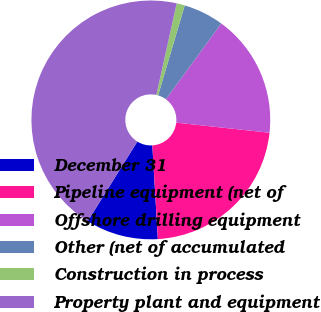<chart> <loc_0><loc_0><loc_500><loc_500><pie_chart><fcel>December 31<fcel>Pipeline equipment (net of<fcel>Offshore drilling equipment<fcel>Other (net of accumulated<fcel>Construction in process<fcel>Property plant and equipment<nl><fcel>9.81%<fcel>22.35%<fcel>16.67%<fcel>5.46%<fcel>1.11%<fcel>44.6%<nl></chart> 